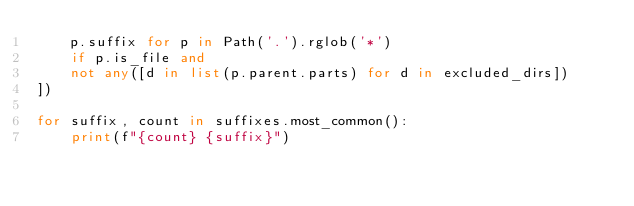Convert code to text. <code><loc_0><loc_0><loc_500><loc_500><_Python_>    p.suffix for p in Path('.').rglob('*')
    if p.is_file and
    not any([d in list(p.parent.parts) for d in excluded_dirs])
])

for suffix, count in suffixes.most_common():
    print(f"{count} {suffix}")
</code> 